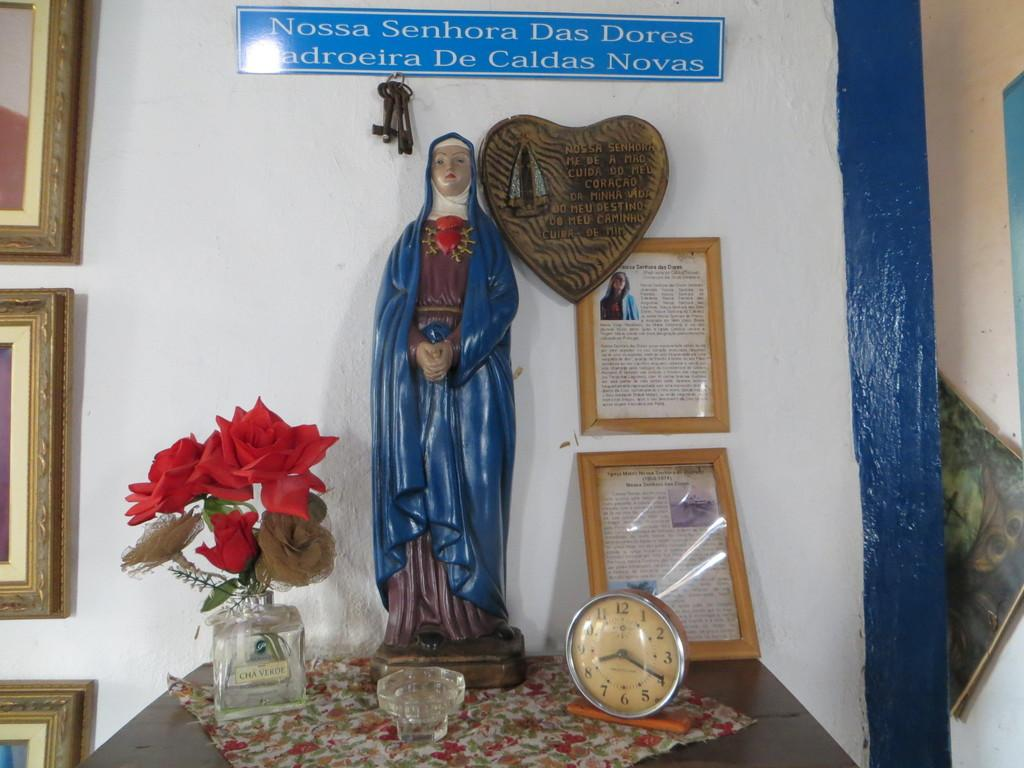<image>
Relay a brief, clear account of the picture shown. A shrine with a saint and a sign that says Nossa Senhora Das Dores on top. 